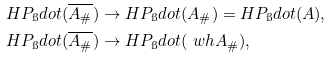<formula> <loc_0><loc_0><loc_500><loc_500>H P _ { \i } d o t ( \overline { A _ { \# } } ) & \to H P _ { \i } d o t ( A _ { \# } ) = H P _ { \i } d o t ( A ) , \\ H P _ { \i } d o t ( \overline { A _ { \# } } ) & \to H P _ { \i } d o t ( \ w h { A _ { \# } } ) ,</formula> 